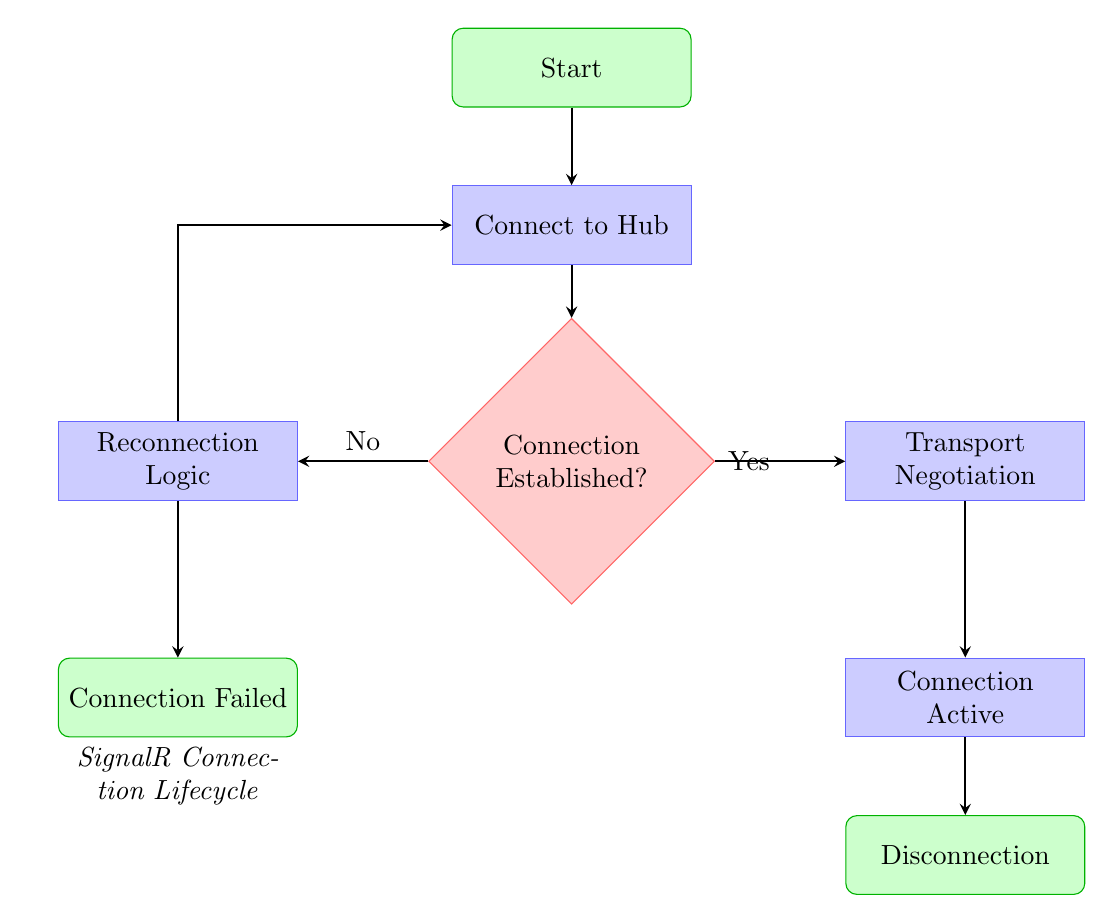What is the first step in the SignalR connection lifecycle? The first step is labeled as "Start," which indicates the initiation of the SignalR connection process.
Answer: Start What is the shape used for "Connection Established"? "Connection Established" is represented as a diamond shape, which indicates a decision point within the flow chart.
Answer: Diamond How many process nodes are there in the diagram? The diagram contains four process nodes, which are "Connect to Hub," "Transport Negotiation," "Reconnection Logic," and "Connection Active."
Answer: Four What happens if the connection to the Hub is not established? If the connection is not established, the flow goes to "Reconnection Logic," which handles connection drops and attempts to reconnect.
Answer: Reconnection Logic What is at the end of the SignalR connection lifecycle? The end of the connection lifecycle is represented by the "Disconnection" node, which indicates the connection is intentionally closed or lost.
Answer: Disconnection What action is taken after "Transport Negotiation"? After "Transport Negotiation," the flow leads to "Connection Active," indicating that the connection is successfully established and active for message exchange.
Answer: Connection Active If "Connection Established" is a yes, which node does the flow move to next? If "Connection Established" is answered with a yes, the flow moves to "Transport Negotiation," which is part of establishing the connection.
Answer: Transport Negotiation How does the diagram handle connection failures? The diagram includes the "Reconnection Logic" node which is responsible for handling connection drops and attempts to reconnect before potentially moving to "Connection Failed" if retries are exhausted.
Answer: Reconnection Logic What is the relationship between "Connection Established" and "Reconnection Logic"? "Connection Established" leads to "Reconnection Logic" in cases where the connection attempt fails, making it a conditional pathway based on the connection status.
Answer: Conditional pathway 